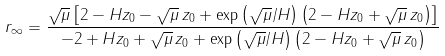<formula> <loc_0><loc_0><loc_500><loc_500>r _ { \infty } = \frac { \sqrt { \mu } \left [ 2 - H z _ { 0 } - \sqrt { \mu } \, z _ { 0 } + \exp \left ( \sqrt { \mu } / H \right ) \left ( 2 - H z _ { 0 } + \sqrt { \mu } \, z _ { 0 } \right ) \right ] } { - 2 + H z _ { 0 } + \sqrt { \mu } \, z _ { 0 } + \exp \left ( \sqrt { \mu } / H \right ) \left ( 2 - H z _ { 0 } + \sqrt { \mu } \, z _ { 0 } \right ) }</formula> 